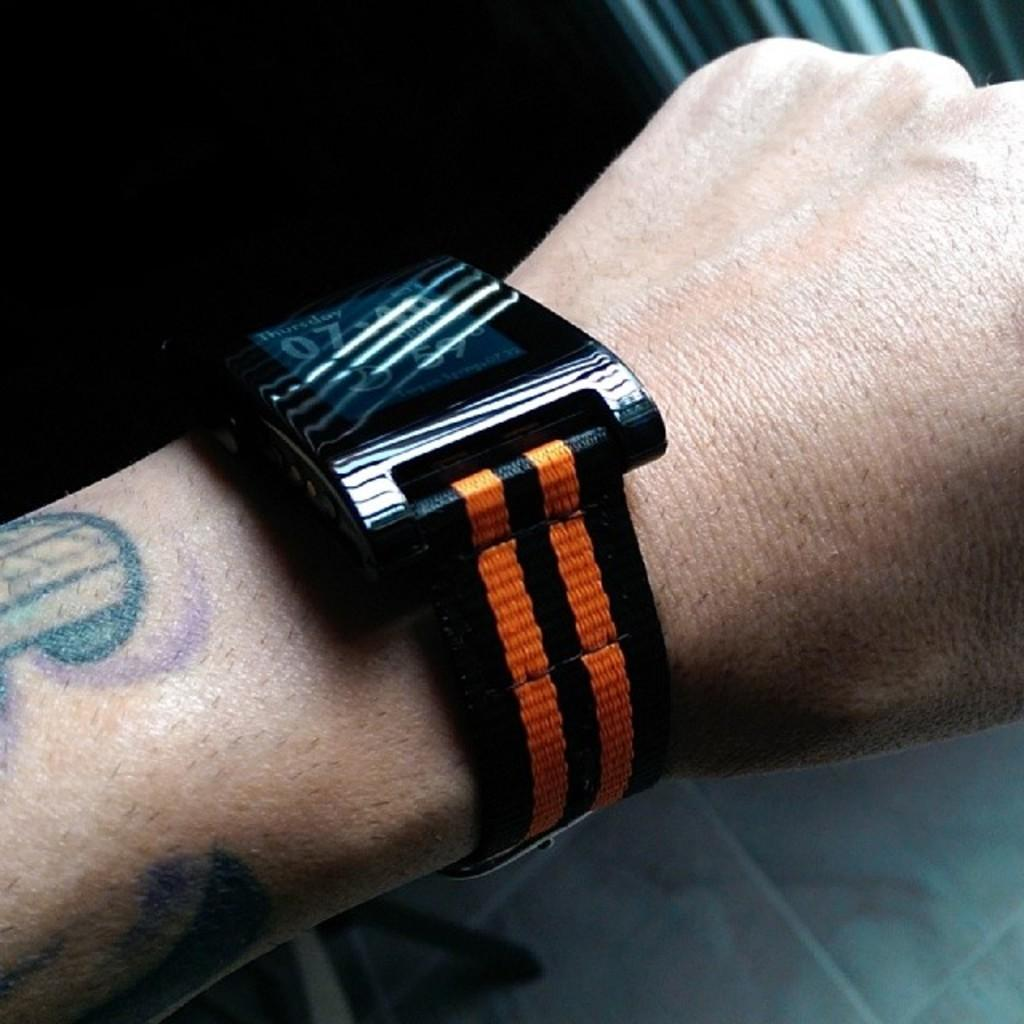<image>
Write a terse but informative summary of the picture. a wrist watch reads Thursday has an orange band 